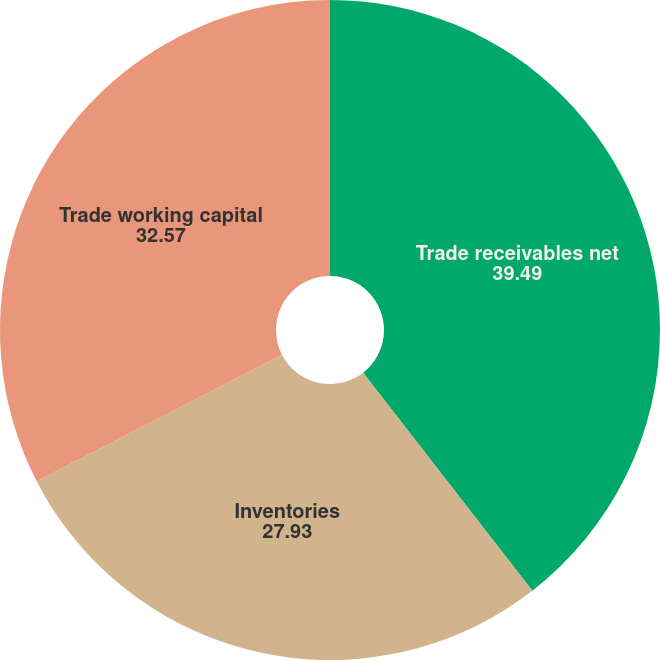Convert chart. <chart><loc_0><loc_0><loc_500><loc_500><pie_chart><fcel>Trade receivables net<fcel>Inventories<fcel>Trade working capital<nl><fcel>39.49%<fcel>27.93%<fcel>32.57%<nl></chart> 